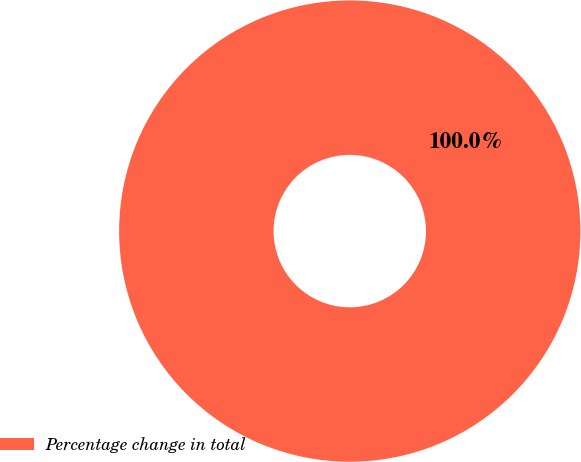Convert chart to OTSL. <chart><loc_0><loc_0><loc_500><loc_500><pie_chart><fcel>Percentage change in total<nl><fcel>100.0%<nl></chart> 